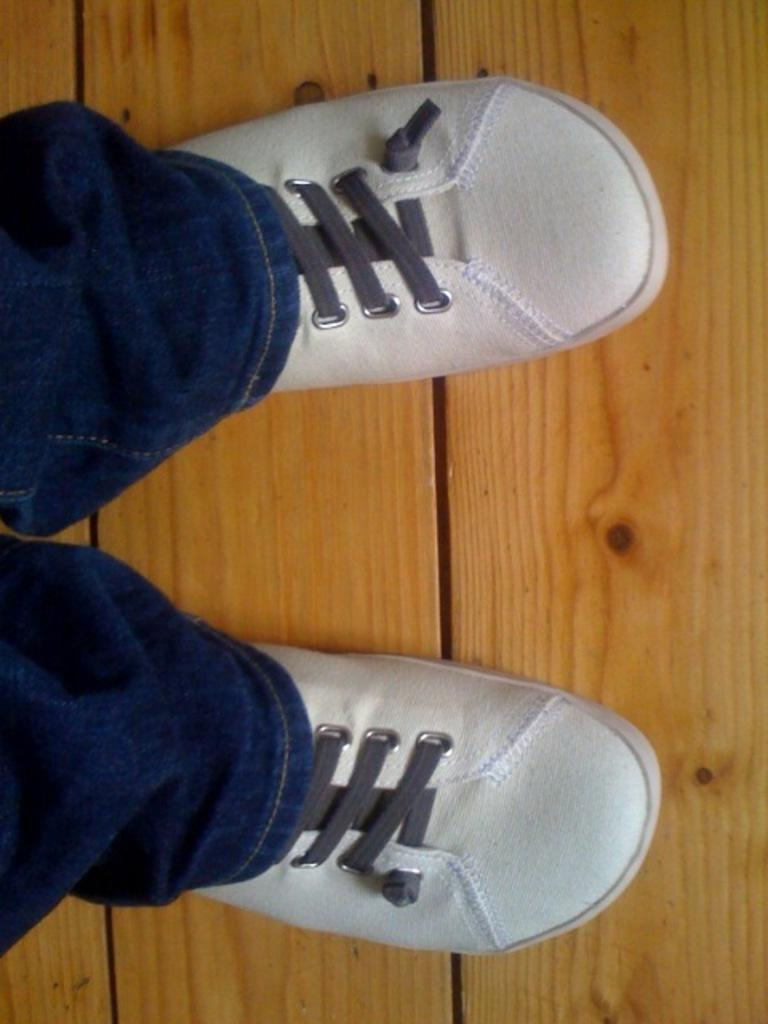Who is present in the image? There is a person in the image. What type of clothing is the person wearing on their lower body? The person is wearing jeans. What type of footwear is the person wearing? The person is wearing white shoes. What material is the surface visible in the image made of? The wooden surface is visible in the image. Is the person's friend in the image? The provided facts do not mention any friends, so we cannot determine if the person's friend is present in the image. What type of authority does the goat have in the image? There is no goat present in the image, so it cannot have any authority. 